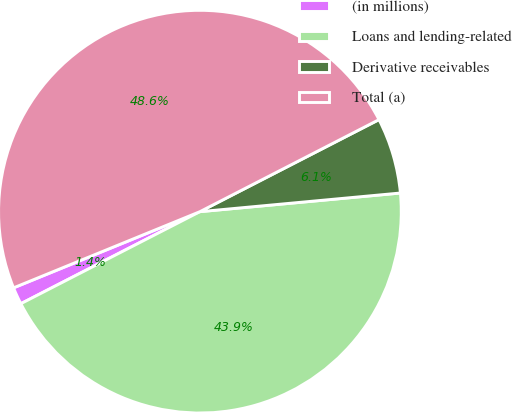Convert chart. <chart><loc_0><loc_0><loc_500><loc_500><pie_chart><fcel>(in millions)<fcel>Loans and lending-related<fcel>Derivative receivables<fcel>Total (a)<nl><fcel>1.38%<fcel>43.92%<fcel>6.08%<fcel>48.62%<nl></chart> 